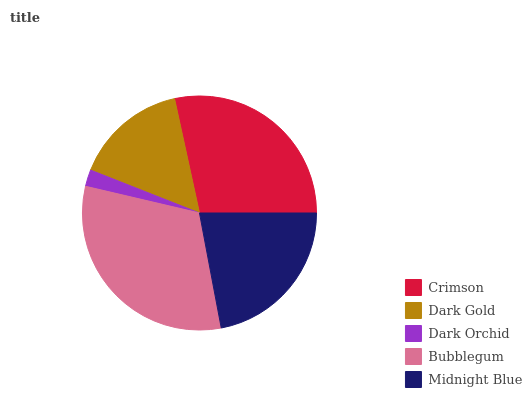Is Dark Orchid the minimum?
Answer yes or no. Yes. Is Bubblegum the maximum?
Answer yes or no. Yes. Is Dark Gold the minimum?
Answer yes or no. No. Is Dark Gold the maximum?
Answer yes or no. No. Is Crimson greater than Dark Gold?
Answer yes or no. Yes. Is Dark Gold less than Crimson?
Answer yes or no. Yes. Is Dark Gold greater than Crimson?
Answer yes or no. No. Is Crimson less than Dark Gold?
Answer yes or no. No. Is Midnight Blue the high median?
Answer yes or no. Yes. Is Midnight Blue the low median?
Answer yes or no. Yes. Is Dark Gold the high median?
Answer yes or no. No. Is Dark Gold the low median?
Answer yes or no. No. 